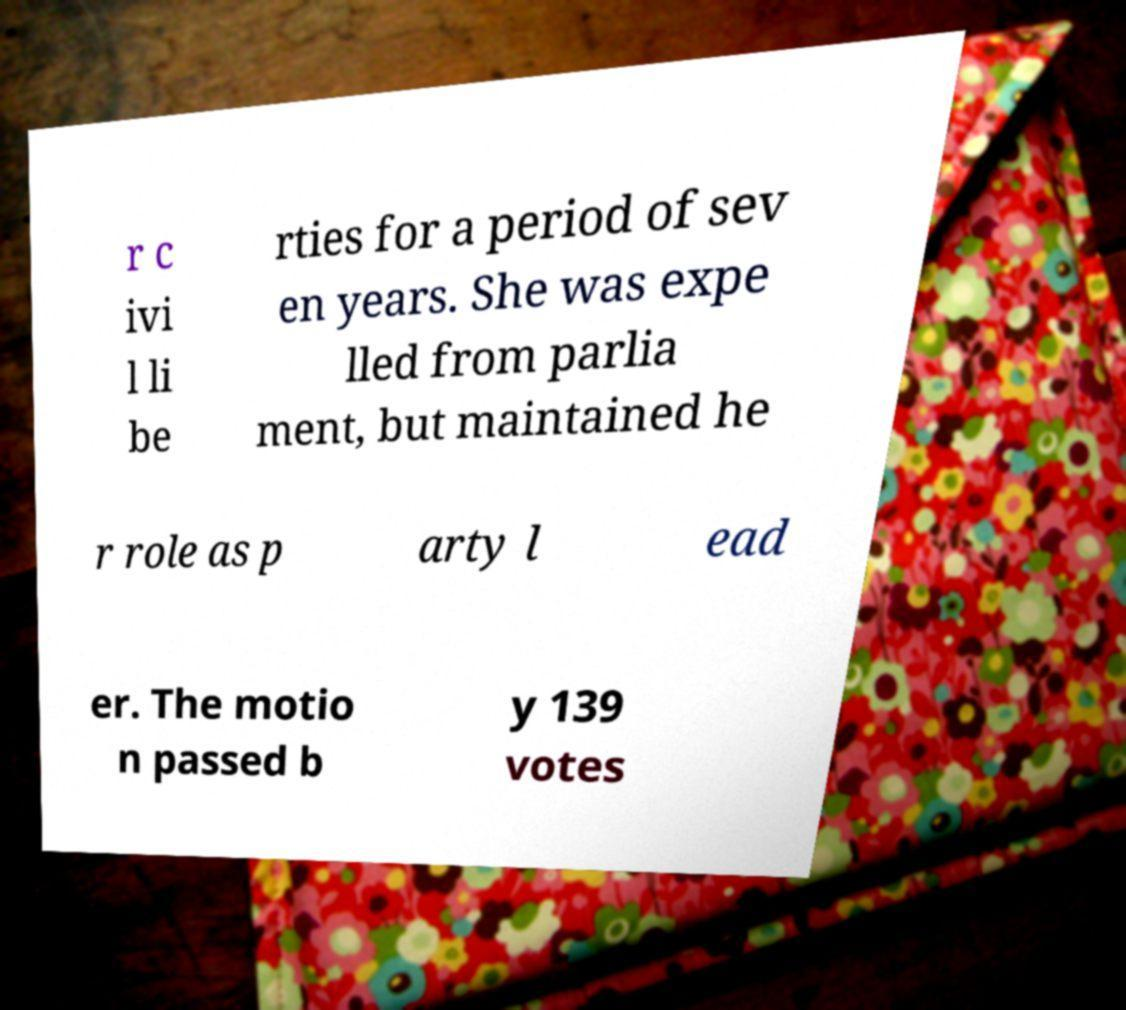Could you extract and type out the text from this image? r c ivi l li be rties for a period of sev en years. She was expe lled from parlia ment, but maintained he r role as p arty l ead er. The motio n passed b y 139 votes 